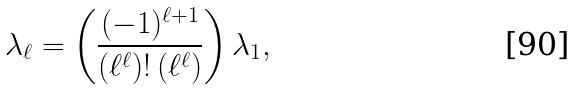Convert formula to latex. <formula><loc_0><loc_0><loc_500><loc_500>\lambda _ { \ell } = \left ( \frac { ( - 1 ) ^ { \ell + 1 } } { \left ( \ell ^ { \ell } \right ) ! \left ( \ell ^ { \ell } \right ) } \right ) \lambda _ { 1 } ,</formula> 